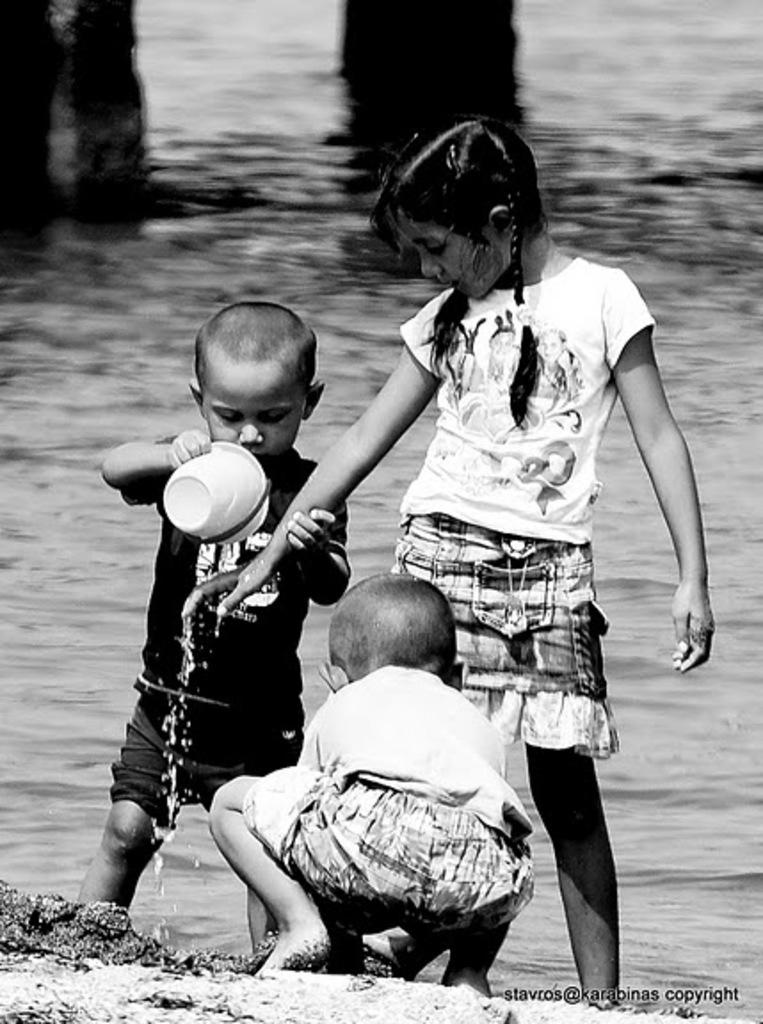How many children are in the image? There are three children in the image. What is the setting of the image? There is sand in the image, which suggests a beach or sandbox. What is the boy holding in his hand? The boy is holding a mug in his hand. What can be seen in the background of the image? There is water visible in the background of the image. What type of jeans is the person wearing in the image? There is no person wearing jeans in the image; the focus is on the three children. How many bites has the child taken out of the mug in the image? The child is not biting into the mug in the image; he is simply holding it. 